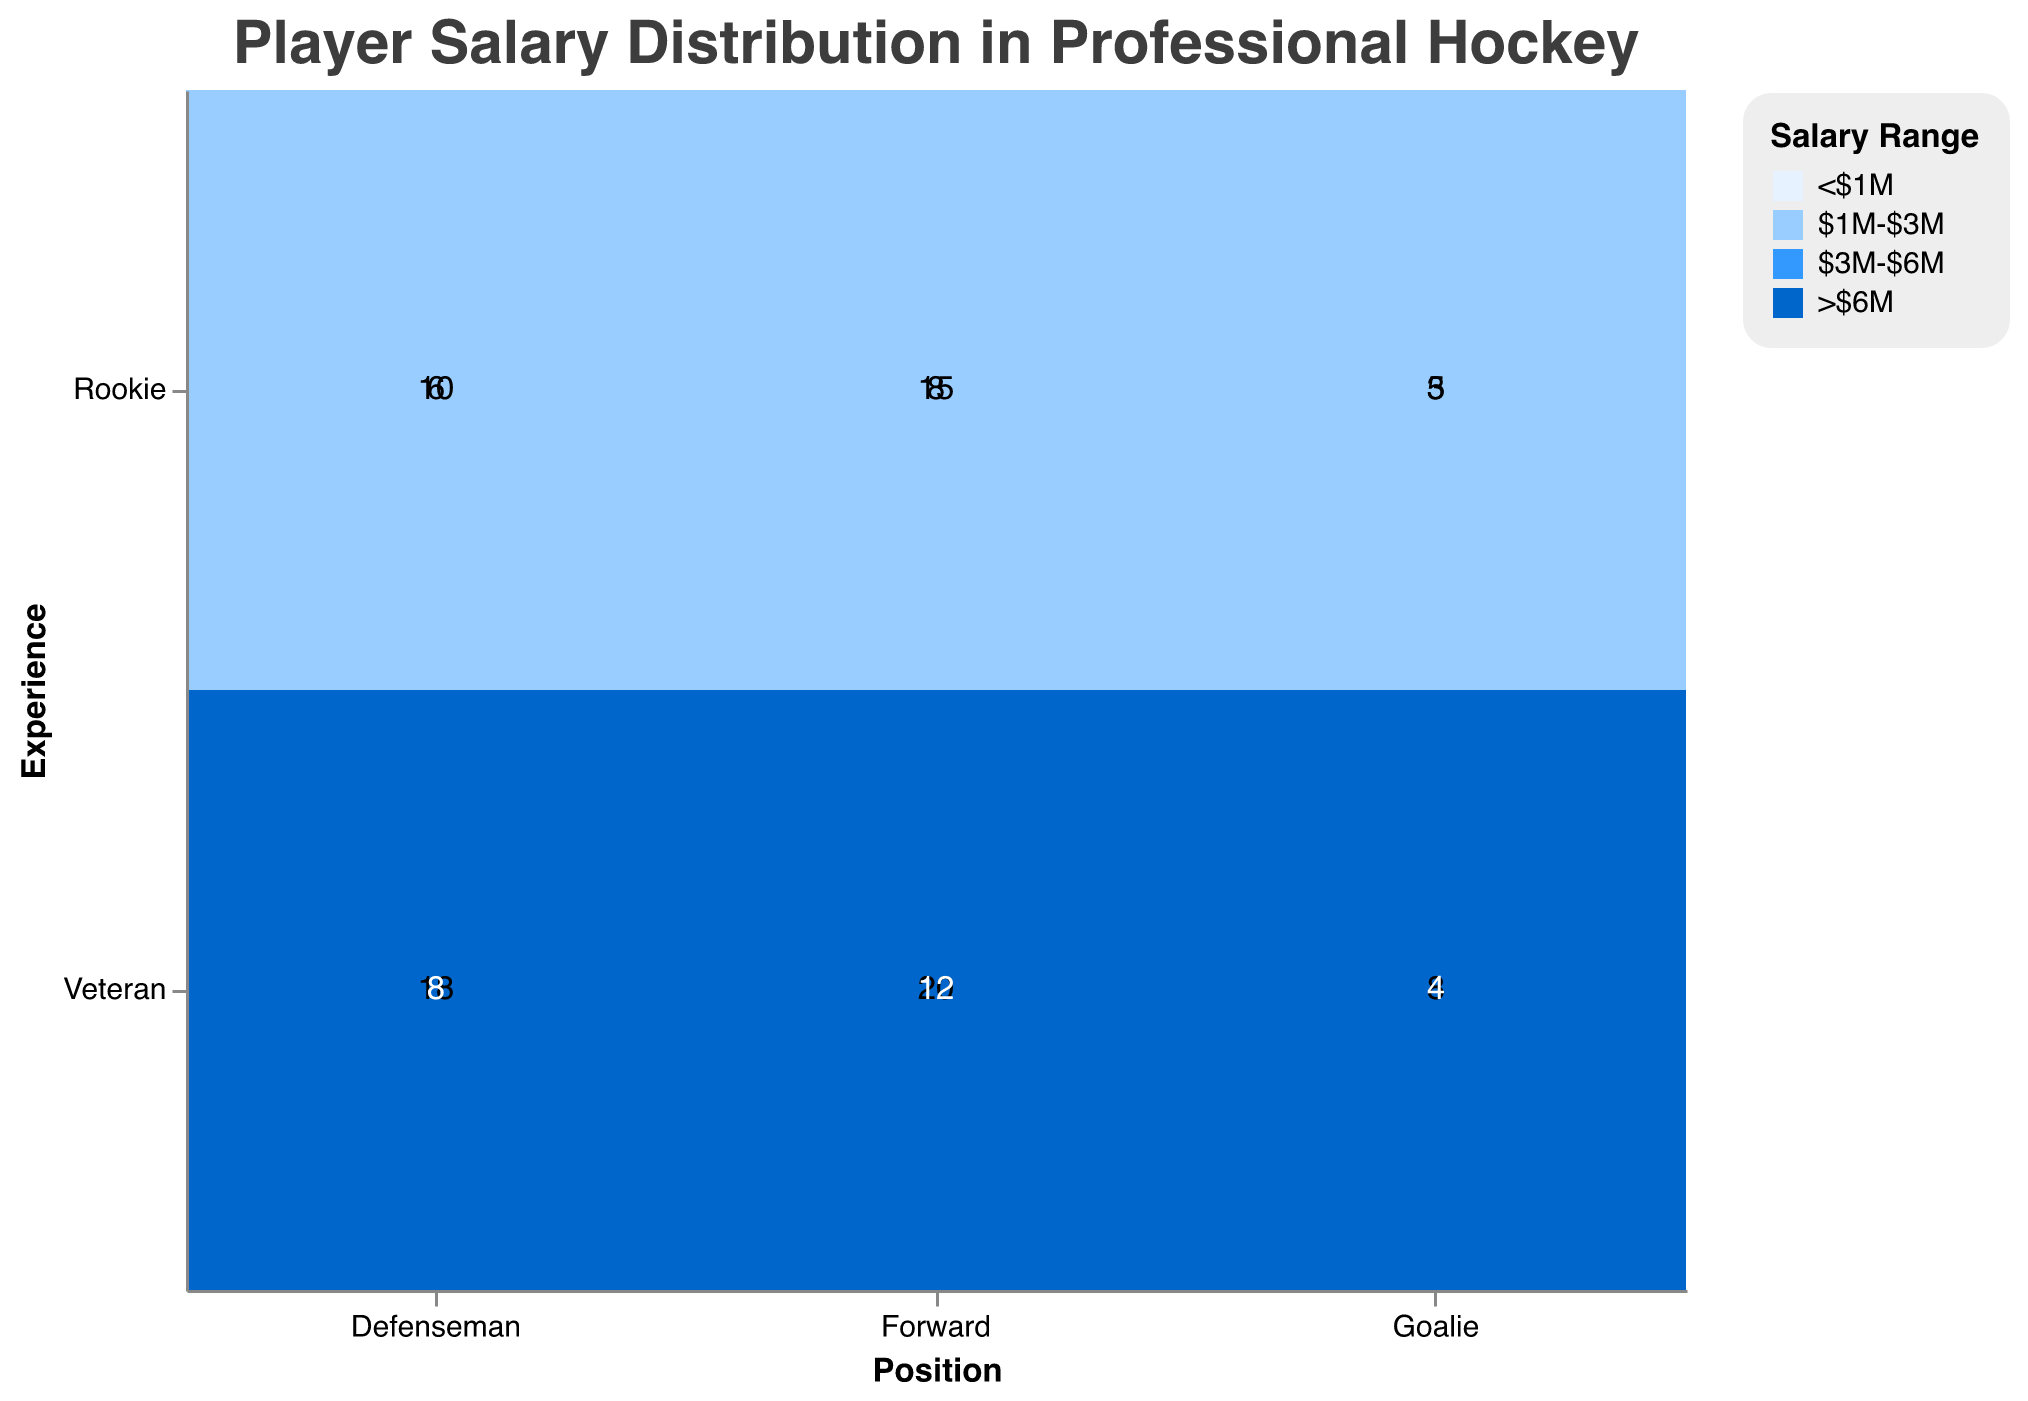What are the four salary ranges represented in the plot? There are four distinct salary ranges shown in the plot's color legend: "<$1M", "$1M-$3M", "$3M-$6M", and ">$6M". Each salary range is represented by a different shade of blue.
Answer: <$1M, $1M-$3M, $3M-$6M, >$6M Which position and experience level has the highest count of players earning between $3M-$6M? By examining the plot, we see that the "Forward" position with "Veteran" experience has the highest count for the salary range "$3M-$6M", which is 20 players.
Answer: Forward, Veteran How many total players are there with the "Rookie" experience level across all positions? Summing up the counts for the "Rookie" experience level across all positions: Forward (15 + 8), Defenseman (10 + 6), and Goalie (5 + 3). So, 15 + 8 + 10 + 6 + 5 + 3 = 47 players.
Answer: 47 Which salary range has the fewest players in the "Goalie" position regardless of experience level? Looking at the two experience levels for the "Goalie" position, the "<$1M" range has 5 and 4 players respectively, totaling to 9. The fewest count is in the "$1M-$3M" range, where there are only 3 players.
Answer: $1M-$3M What is the most common salary range for "Defenseman" with veteran experience? For "Defenseman" with veteran experience, the counts for each salary range are "$3M-$6M" with 18 and ">$6M" with 8, so the most common is "$3M-$6M" with 18 players.
Answer: $3M-$6M Compare the number of rookie forwards earning less than $1M to veteran goalies earning more than $6M. The number of rookie forwards earning less than $1M is 15, whereas the number of veteran goalies earning more than $6M is 4. Comparing these, 15 is greater than 4.
Answer: 15 is greater than 4 How does the number of players in the <$1M salary range for rookies compare to veterans across all positions combined? Adding the counts for all rookies in the "<$1M" range: Forward (15), Defenseman (10), and Goalie (5), we get 30. Adding the counts for all veterans in the "<$1M" range: there are none. Thus, rookies have significantly more players (30) in the "<$1M" range than veterans (0).
Answer: 30 rookies, 0 veterans For which position is the distribution of salaries most evenly spread across all experience levels and salary ranges? Evaluating the counts for each position, we see that the "Defenseman" position seems to have a more even distribution across different salary ranges and experience levels compared to "Forward" and "Goalie".
Answer: Defenseman How many players earn more than $6M in total? Summing up the counts for players earning more than $6M across all categories: Forward Veteran (12), Defenseman Veteran (8), and Goalie Veteran (4), we get 12 + 8 + 4 = 24 players in total.
Answer: 24 Which experience level has a higher number of players earning between $1M-$3M for the Forward position? Looking at the counts for the Forward position, the "Rookie" experience level has 8 players earning between $1M-$3M, while the "Veteran" experience level is not relevant as they appear in higher ranges. Therefore, "Rookie" has all 8 players in this range.
Answer: Rookie 